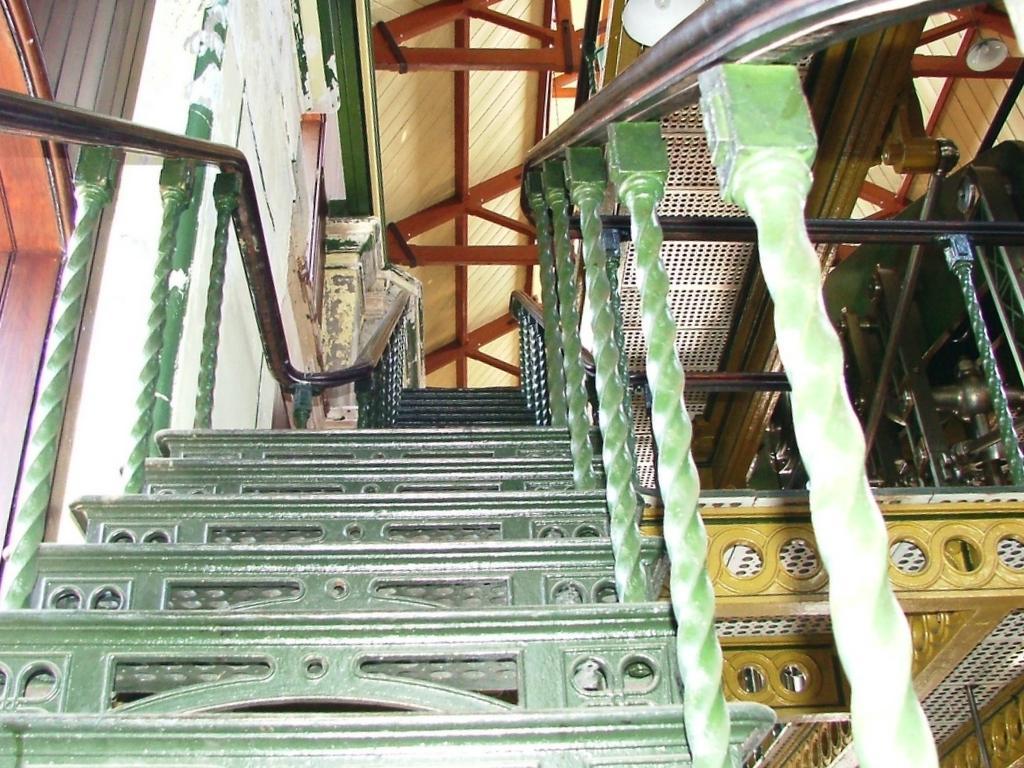How would you summarize this image in a sentence or two? In this picture we can see stairs here, we can see ceiling at the top of the picture, there is a railing here, on the left side there is a wall. 